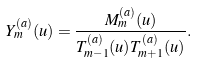<formula> <loc_0><loc_0><loc_500><loc_500>Y ^ { ( a ) } _ { m } ( u ) = \frac { M ^ { ( a ) } _ { m } ( u ) } { T ^ { ( a ) } _ { m - 1 } ( u ) T ^ { ( a ) } _ { m + 1 } ( u ) } .</formula> 